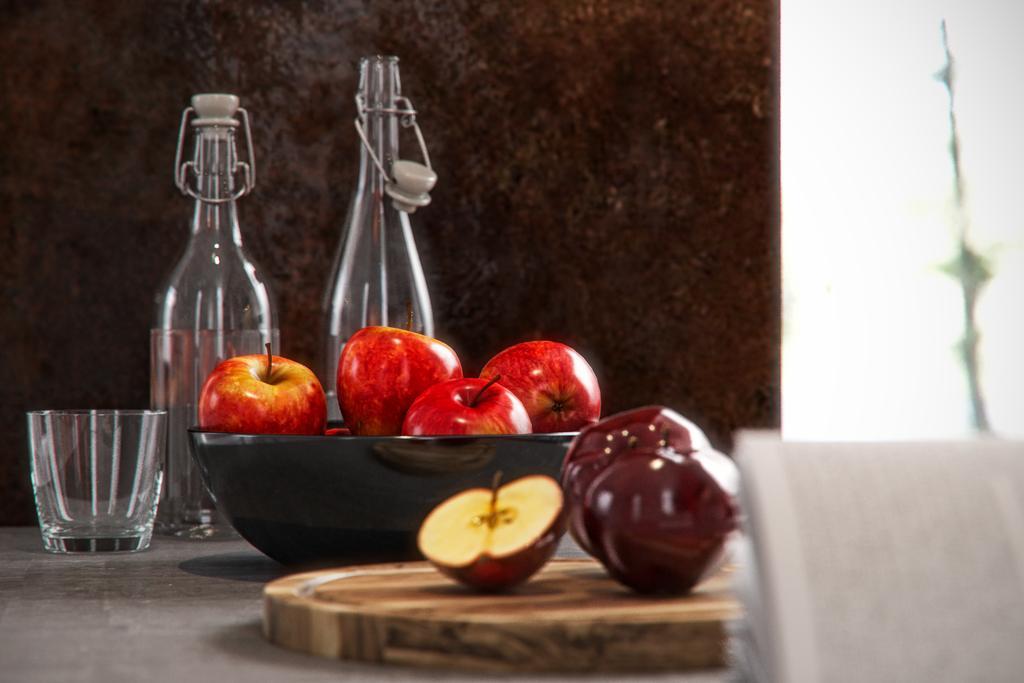In one or two sentences, can you explain what this image depicts? In this picture we can see a wall, and a glass bottle on the table, and a glass, with a bowl of apples, and a half cut apple on it. 